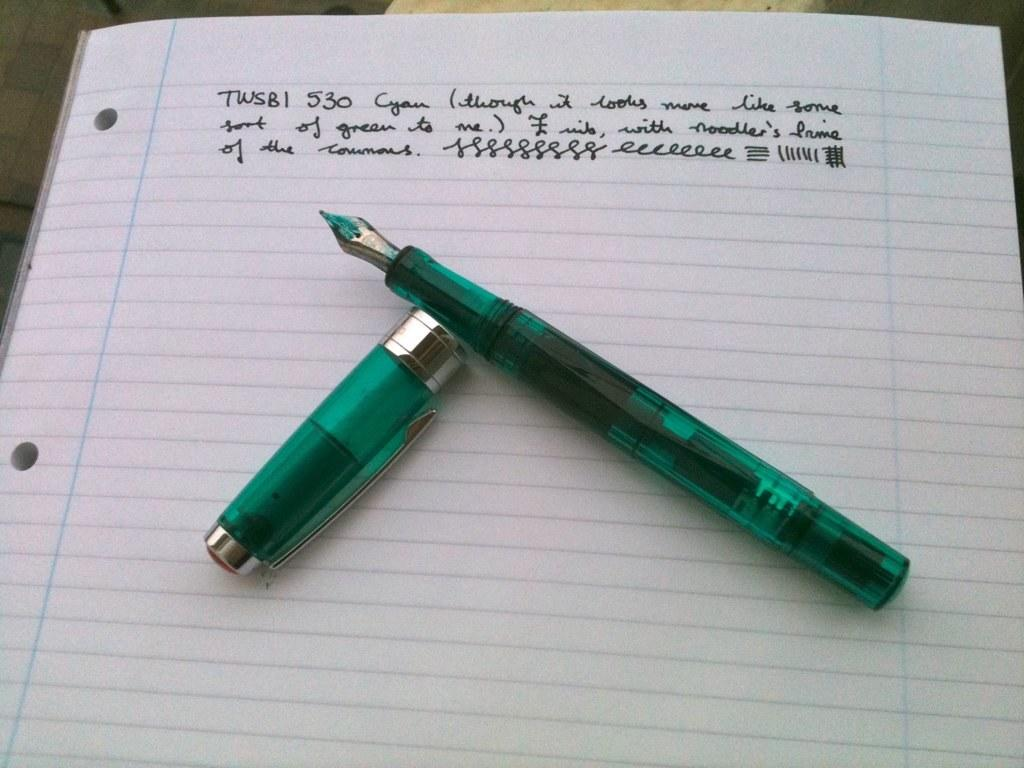What is the main object in the image? There is a book in the image. What is placed on top of the book? There is a pen on the book. What color is the pen? The pen is green in color. Can you describe any text on the book? Yes, there are words written on the book. How many chickens are visible in the image? There are no chickens present in the image. What type of tool does the carpenter use in the image? There is no carpenter or tool present in the image. 